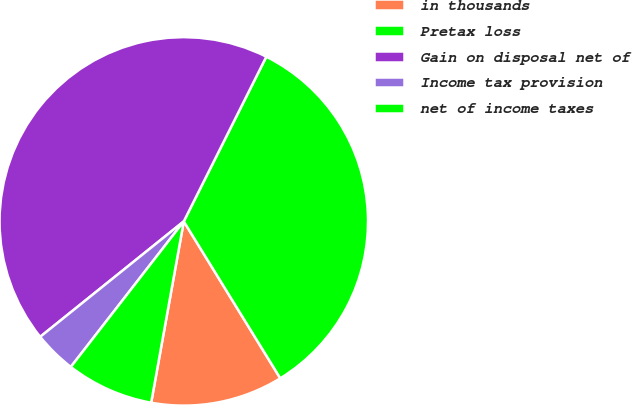Convert chart to OTSL. <chart><loc_0><loc_0><loc_500><loc_500><pie_chart><fcel>in thousands<fcel>Pretax loss<fcel>Gain on disposal net of<fcel>Income tax provision<fcel>net of income taxes<nl><fcel>11.61%<fcel>33.83%<fcel>43.17%<fcel>3.72%<fcel>7.67%<nl></chart> 